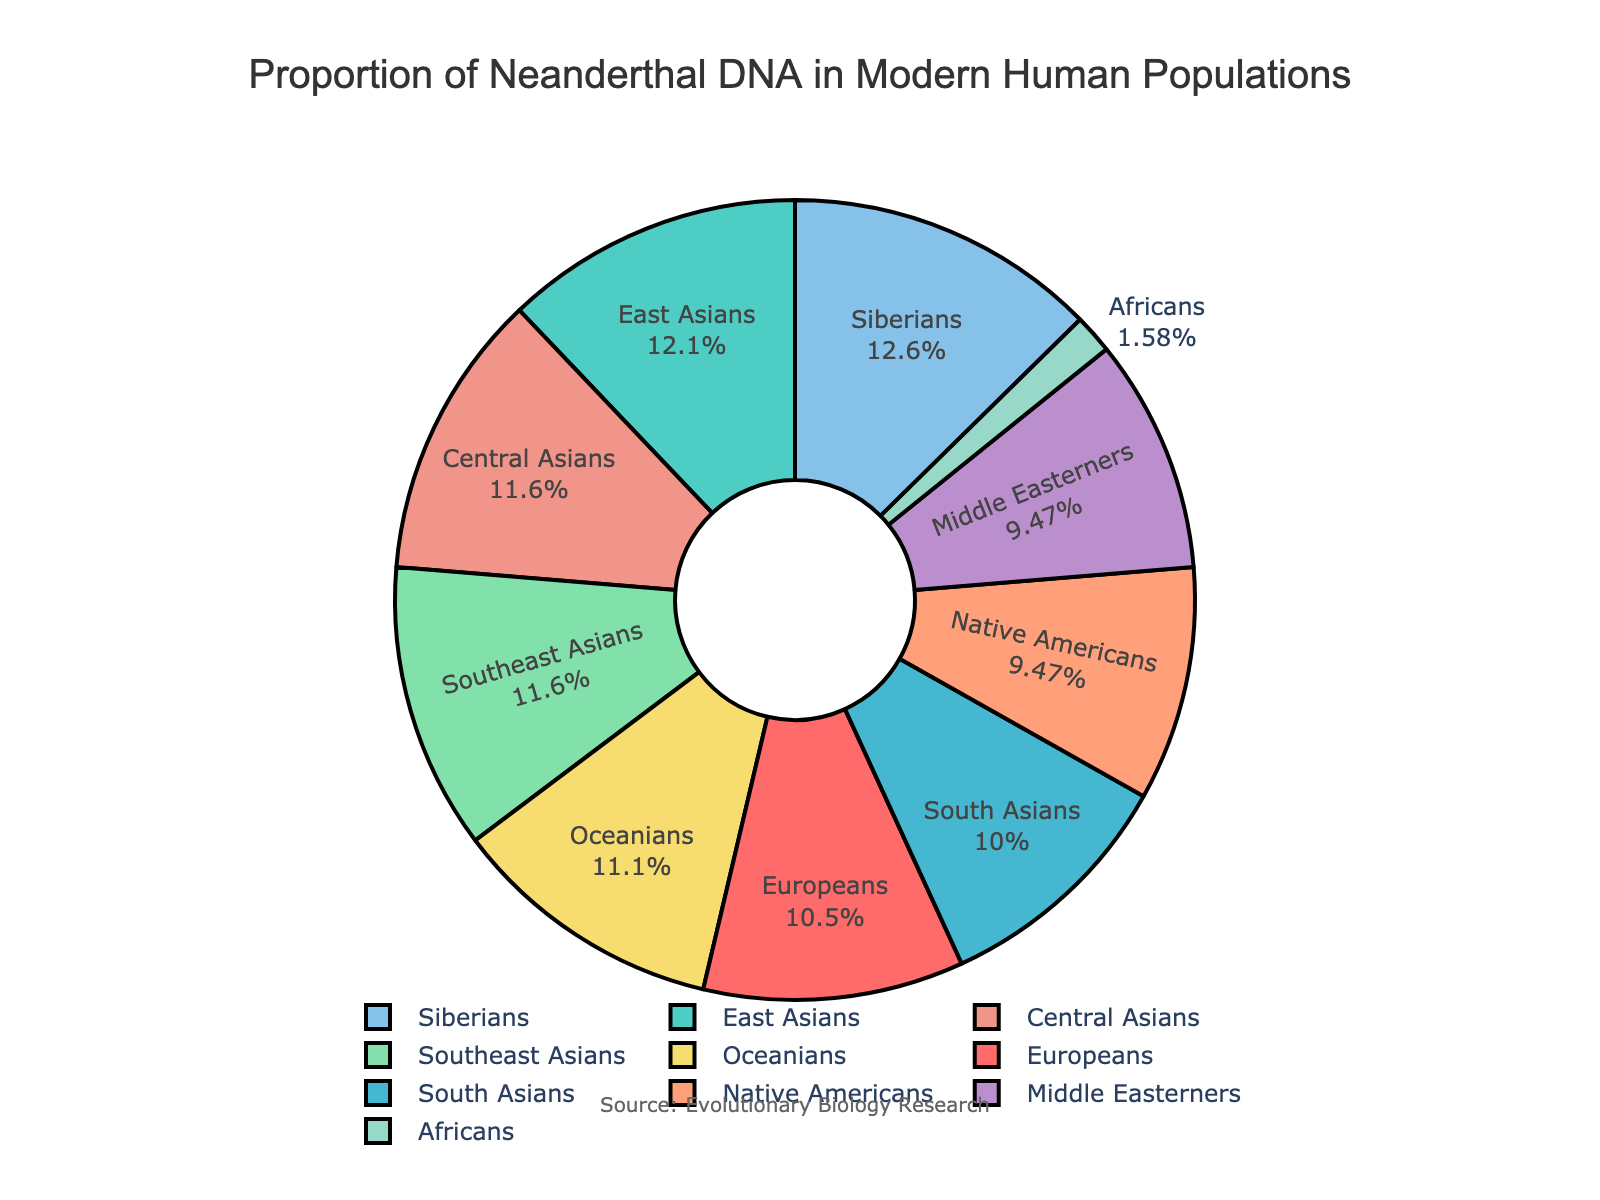Which population has the highest proportion of Neanderthal DNA? By looking at the pie chart, Siberians have the largest slice, indicating the highest proportion of Neanderthal DNA.
Answer: Siberians Which population has the lowest proportion of Neanderthal DNA? By observing the pie chart, the portion for Africans is the smallest, indicating the lowest proportion of Neanderthal DNA.
Answer: Africans What is the sum of the proportions of Neanderthal DNA for Europeans and Oceanians? Europeans have 2.0% and Oceanians have 2.1%. Summing these values gives 4.1%.
Answer: 4.1% Which populations have a proportion of Neanderthal DNA greater than 2%? By inspecting the pie chart, East Asians, Oceanians, Central Asians, Siberians, and Southeast Asians have slices larger than 2%.
Answer: East Asians, Oceanians, Central Asians, Siberians, Southeast Asians How many populations have a proportion of Neanderthal DNA less than 2%? Counting the slices in the pie chart that are less than 2%, we find that South Asians, Native Americans, Africans, and Middle Easterners fit this criteria. There are 4 populations.
Answer: 4 What is the median proportion of Neanderthal DNA among all the populations? Ordering the proportions: 0.3, 1.8, 1.8, 1.9, 2.0, 2.1, 2.2, 2.2, 2.3, 2.4, the median falls between 2.0 and 2.1. Thus, the median is (2.0 + 2.1)/2 = 2.05.
Answer: 2.05 Which populations share the same proportion of Neanderthal DNA? Central Asians and Southeast Asians both have proportions of 2.2%. Additionally, Native Americans and Middle Easterners both have 1.8%.
Answer: Central Asians and Southeast Asians, Native Americans and Middle Easterners What is the difference between the highest and lowest proportions of Neanderthal DNA? The highest proportion is 2.4% (Siberians) and the lowest is 0.3% (Africans). The difference is 2.4% - 0.3% = 2.1%.
Answer: 2.1% What is the average proportion of Neanderthal DNA across all populations? Summing all proportions: 2.0 + 2.3 + 1.9 + 1.8 + 0.3 + 2.1 + 1.8 + 2.2 + 2.4 + 2.2 = 18.0. Dividing by the number of populations (10) yields 18.0 / 10 = 1.8.
Answer: 1.8 Which population's proportion is represented by the green color? By observing the color legend tied to the pie slices, the green slice corresponds to East Asians.
Answer: East Asians 